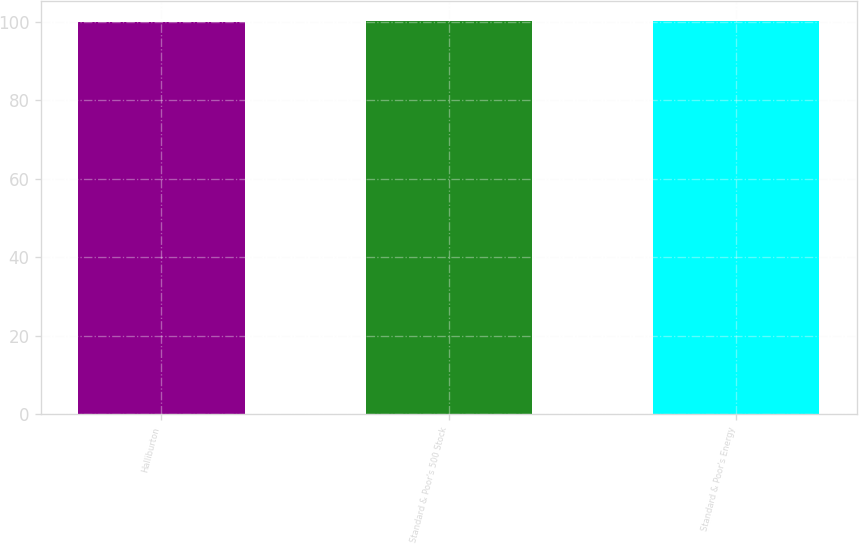Convert chart. <chart><loc_0><loc_0><loc_500><loc_500><bar_chart><fcel>Halliburton<fcel>Standard & Poor's 500 Stock<fcel>Standard & Poor's Energy<nl><fcel>100<fcel>100.1<fcel>100.2<nl></chart> 